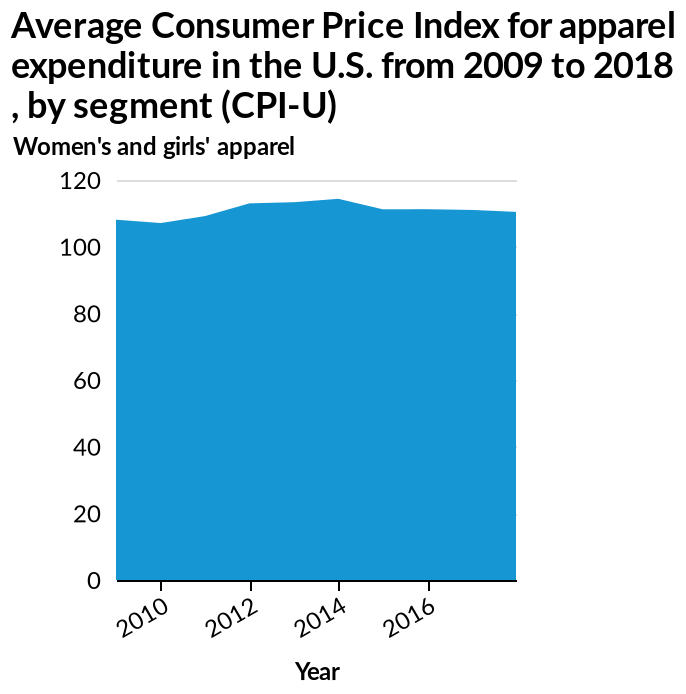<image>
Describe the following image in detail Average Consumer Price Index for apparel expenditure in the U.S. from 2009 to 2018 , by segment (CPI-U) is a area plot. The y-axis plots Women's and girls' apparel using a linear scale from 0 to 120. There is a linear scale of range 2010 to 2016 on the x-axis, marked Year. Did the expenditure drop after 2014?  Yes, the expenditure dropped down again after 2014. Was there any increase in expenditure between 2012 and 2014?  Yes, there was an increase in expenditure to approximately 110 between 2012 and 2014. Offer a thorough analysis of the image. There is a slow decline from 2009 up until 2010 in women and girls apparel. From the year onwards  2010 there is a steady increase until the year 2015 where there is stagnation towards the year 2016 and onwards. 